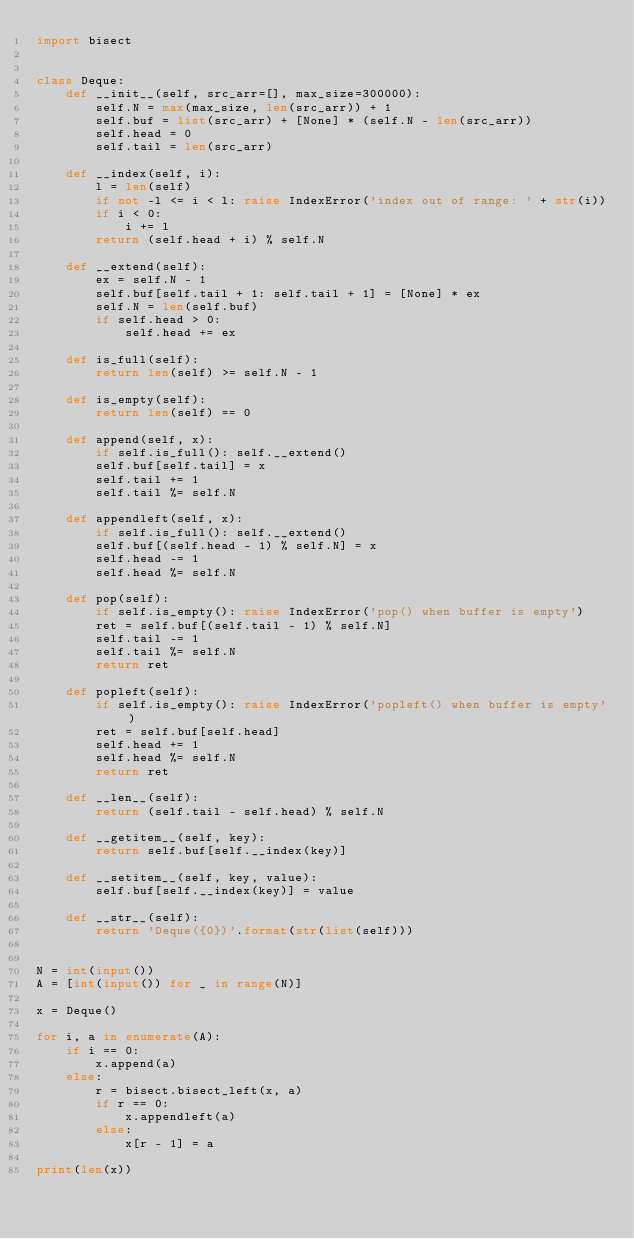Convert code to text. <code><loc_0><loc_0><loc_500><loc_500><_Python_>import bisect


class Deque:
    def __init__(self, src_arr=[], max_size=300000):
        self.N = max(max_size, len(src_arr)) + 1
        self.buf = list(src_arr) + [None] * (self.N - len(src_arr))
        self.head = 0
        self.tail = len(src_arr)

    def __index(self, i):
        l = len(self)
        if not -l <= i < l: raise IndexError('index out of range: ' + str(i))
        if i < 0:
            i += l
        return (self.head + i) % self.N

    def __extend(self):
        ex = self.N - 1
        self.buf[self.tail + 1: self.tail + 1] = [None] * ex
        self.N = len(self.buf)
        if self.head > 0:
            self.head += ex

    def is_full(self):
        return len(self) >= self.N - 1

    def is_empty(self):
        return len(self) == 0

    def append(self, x):
        if self.is_full(): self.__extend()
        self.buf[self.tail] = x
        self.tail += 1
        self.tail %= self.N

    def appendleft(self, x):
        if self.is_full(): self.__extend()
        self.buf[(self.head - 1) % self.N] = x
        self.head -= 1
        self.head %= self.N

    def pop(self):
        if self.is_empty(): raise IndexError('pop() when buffer is empty')
        ret = self.buf[(self.tail - 1) % self.N]
        self.tail -= 1
        self.tail %= self.N
        return ret

    def popleft(self):
        if self.is_empty(): raise IndexError('popleft() when buffer is empty')
        ret = self.buf[self.head]
        self.head += 1
        self.head %= self.N
        return ret

    def __len__(self):
        return (self.tail - self.head) % self.N

    def __getitem__(self, key):
        return self.buf[self.__index(key)]

    def __setitem__(self, key, value):
        self.buf[self.__index(key)] = value

    def __str__(self):
        return 'Deque({0})'.format(str(list(self)))


N = int(input())
A = [int(input()) for _ in range(N)]

x = Deque()

for i, a in enumerate(A):
    if i == 0:
        x.append(a)
    else:
        r = bisect.bisect_left(x, a)
        if r == 0:
            x.appendleft(a)
        else:
            x[r - 1] = a

print(len(x))
</code> 